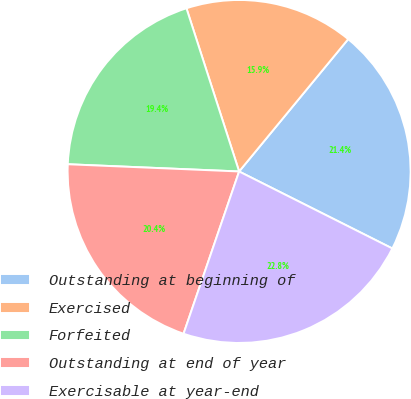Convert chart. <chart><loc_0><loc_0><loc_500><loc_500><pie_chart><fcel>Outstanding at beginning of<fcel>Exercised<fcel>Forfeited<fcel>Outstanding at end of year<fcel>Exercisable at year-end<nl><fcel>21.44%<fcel>15.94%<fcel>19.36%<fcel>20.42%<fcel>22.84%<nl></chart> 